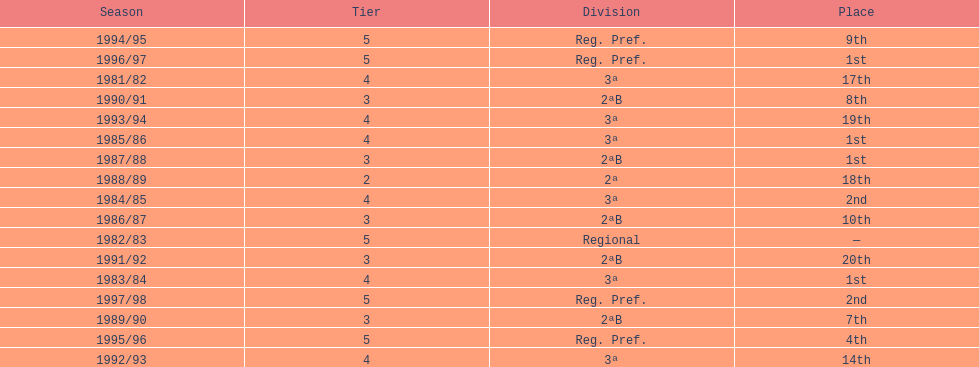When is the last year that the team has been division 2? 1991/92. 